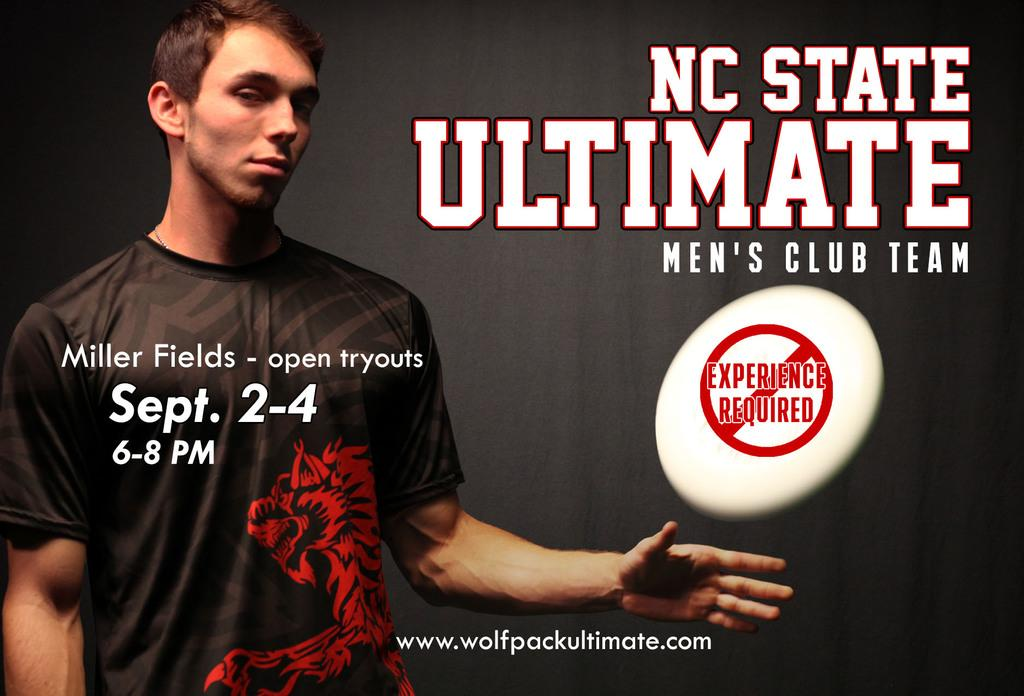Who is present in the image? There is a man in the image. Where is the man located in the image? The man is on the left side of the image. What else can be seen in the image besides the man? There is text in the image. What type of card is the man holding in the image? There is no card present in the image; the man is not holding anything. 